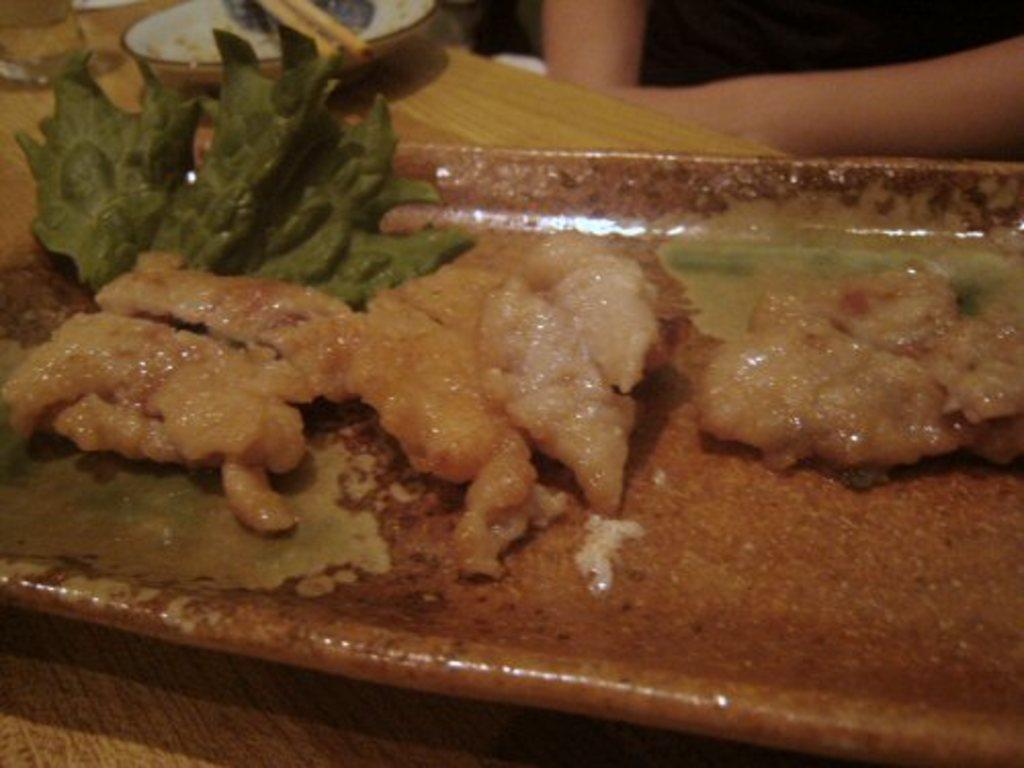Can you describe this image briefly? There is some food item served on a plate and beside that there are two chopsticks kept on a saucer. A person is sitting in front of the table. 